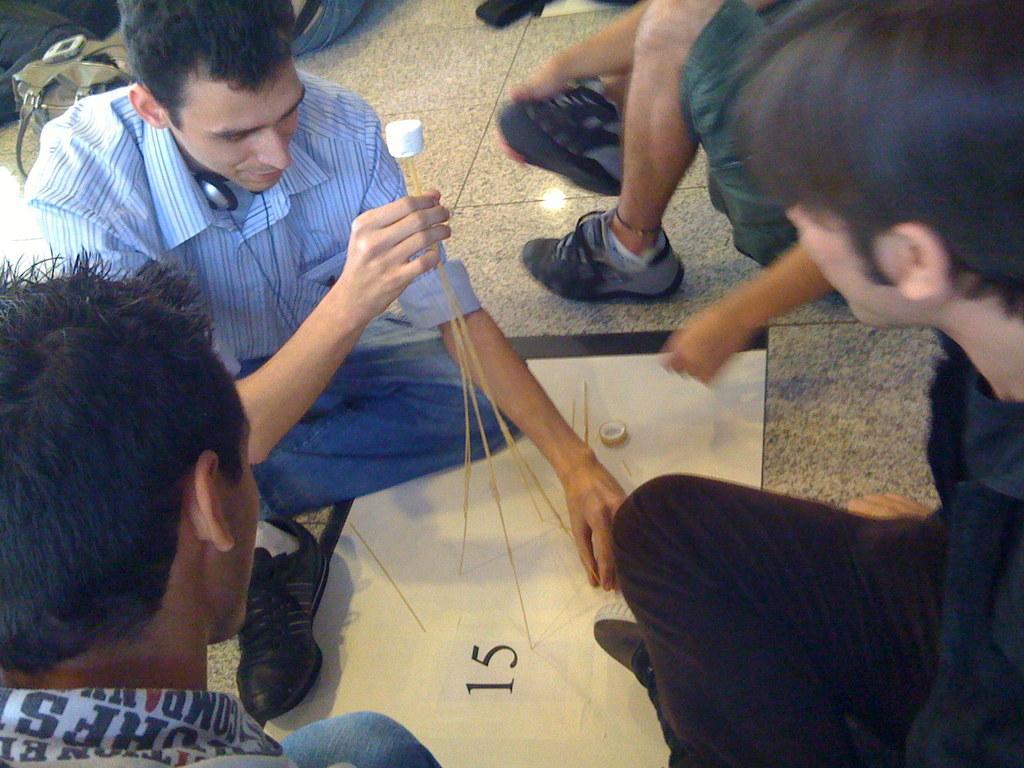Could you give a brief overview of what you see in this image? In the center of the image we can see a few people are in different costumes. Among them, we can see one person is holding some objects. Between them, we can see the paper. And we can see some numbers, one tape and thin sticks on the paper. In the background, we can see a few other objects. 